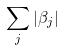<formula> <loc_0><loc_0><loc_500><loc_500>\sum _ { j } | \beta _ { j } |</formula> 